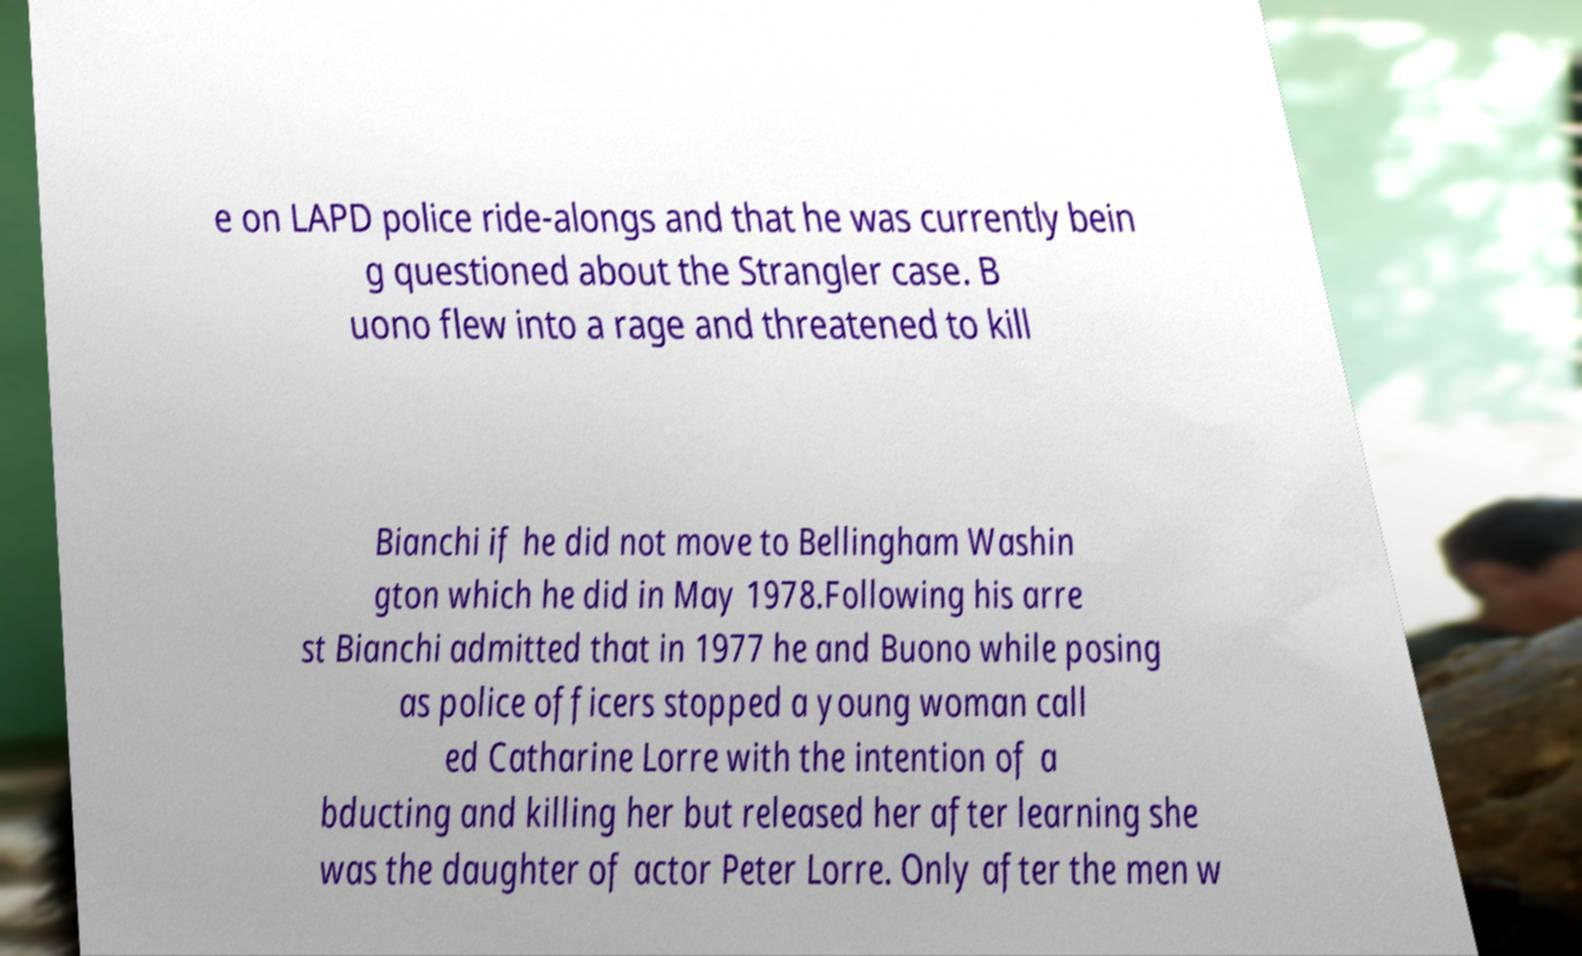What messages or text are displayed in this image? I need them in a readable, typed format. e on LAPD police ride-alongs and that he was currently bein g questioned about the Strangler case. B uono flew into a rage and threatened to kill Bianchi if he did not move to Bellingham Washin gton which he did in May 1978.Following his arre st Bianchi admitted that in 1977 he and Buono while posing as police officers stopped a young woman call ed Catharine Lorre with the intention of a bducting and killing her but released her after learning she was the daughter of actor Peter Lorre. Only after the men w 